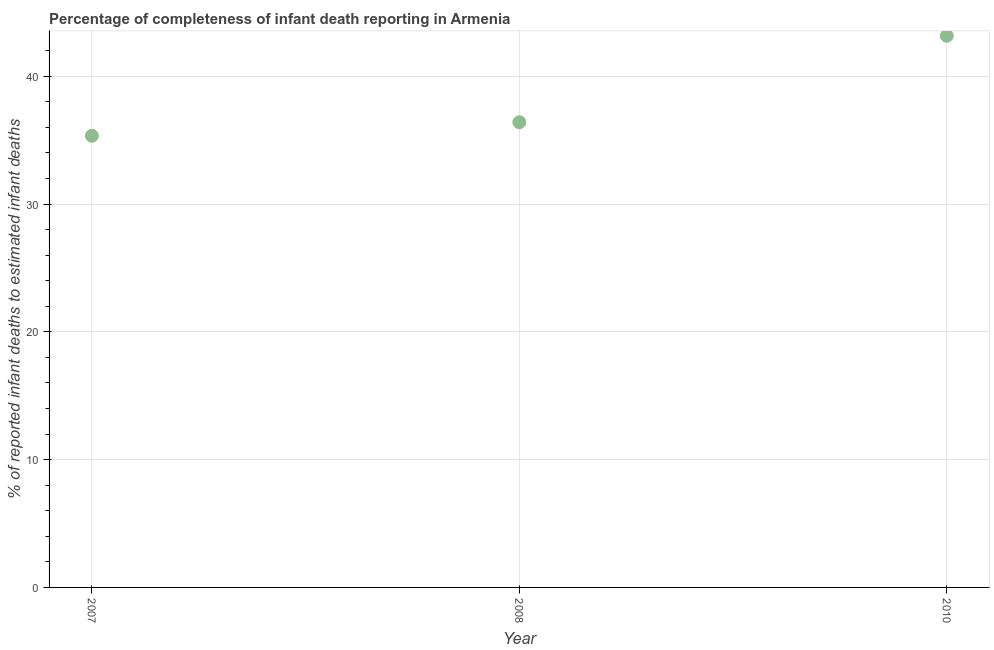What is the completeness of infant death reporting in 2010?
Ensure brevity in your answer.  43.17. Across all years, what is the maximum completeness of infant death reporting?
Offer a very short reply. 43.17. Across all years, what is the minimum completeness of infant death reporting?
Your answer should be very brief. 35.35. In which year was the completeness of infant death reporting maximum?
Ensure brevity in your answer.  2010. What is the sum of the completeness of infant death reporting?
Offer a very short reply. 114.93. What is the difference between the completeness of infant death reporting in 2007 and 2008?
Make the answer very short. -1.06. What is the average completeness of infant death reporting per year?
Offer a terse response. 38.31. What is the median completeness of infant death reporting?
Provide a succinct answer. 36.41. In how many years, is the completeness of infant death reporting greater than 28 %?
Provide a short and direct response. 3. What is the ratio of the completeness of infant death reporting in 2008 to that in 2010?
Offer a very short reply. 0.84. Is the difference between the completeness of infant death reporting in 2007 and 2008 greater than the difference between any two years?
Give a very brief answer. No. What is the difference between the highest and the second highest completeness of infant death reporting?
Your answer should be compact. 6.76. Is the sum of the completeness of infant death reporting in 2007 and 2008 greater than the maximum completeness of infant death reporting across all years?
Provide a short and direct response. Yes. What is the difference between the highest and the lowest completeness of infant death reporting?
Make the answer very short. 7.82. Does the completeness of infant death reporting monotonically increase over the years?
Your answer should be compact. Yes. How many dotlines are there?
Your response must be concise. 1. How many years are there in the graph?
Offer a very short reply. 3. Does the graph contain any zero values?
Provide a short and direct response. No. Does the graph contain grids?
Ensure brevity in your answer.  Yes. What is the title of the graph?
Provide a short and direct response. Percentage of completeness of infant death reporting in Armenia. What is the label or title of the X-axis?
Keep it short and to the point. Year. What is the label or title of the Y-axis?
Ensure brevity in your answer.  % of reported infant deaths to estimated infant deaths. What is the % of reported infant deaths to estimated infant deaths in 2007?
Make the answer very short. 35.35. What is the % of reported infant deaths to estimated infant deaths in 2008?
Make the answer very short. 36.41. What is the % of reported infant deaths to estimated infant deaths in 2010?
Your response must be concise. 43.17. What is the difference between the % of reported infant deaths to estimated infant deaths in 2007 and 2008?
Ensure brevity in your answer.  -1.06. What is the difference between the % of reported infant deaths to estimated infant deaths in 2007 and 2010?
Provide a short and direct response. -7.82. What is the difference between the % of reported infant deaths to estimated infant deaths in 2008 and 2010?
Make the answer very short. -6.76. What is the ratio of the % of reported infant deaths to estimated infant deaths in 2007 to that in 2008?
Give a very brief answer. 0.97. What is the ratio of the % of reported infant deaths to estimated infant deaths in 2007 to that in 2010?
Your response must be concise. 0.82. What is the ratio of the % of reported infant deaths to estimated infant deaths in 2008 to that in 2010?
Keep it short and to the point. 0.84. 